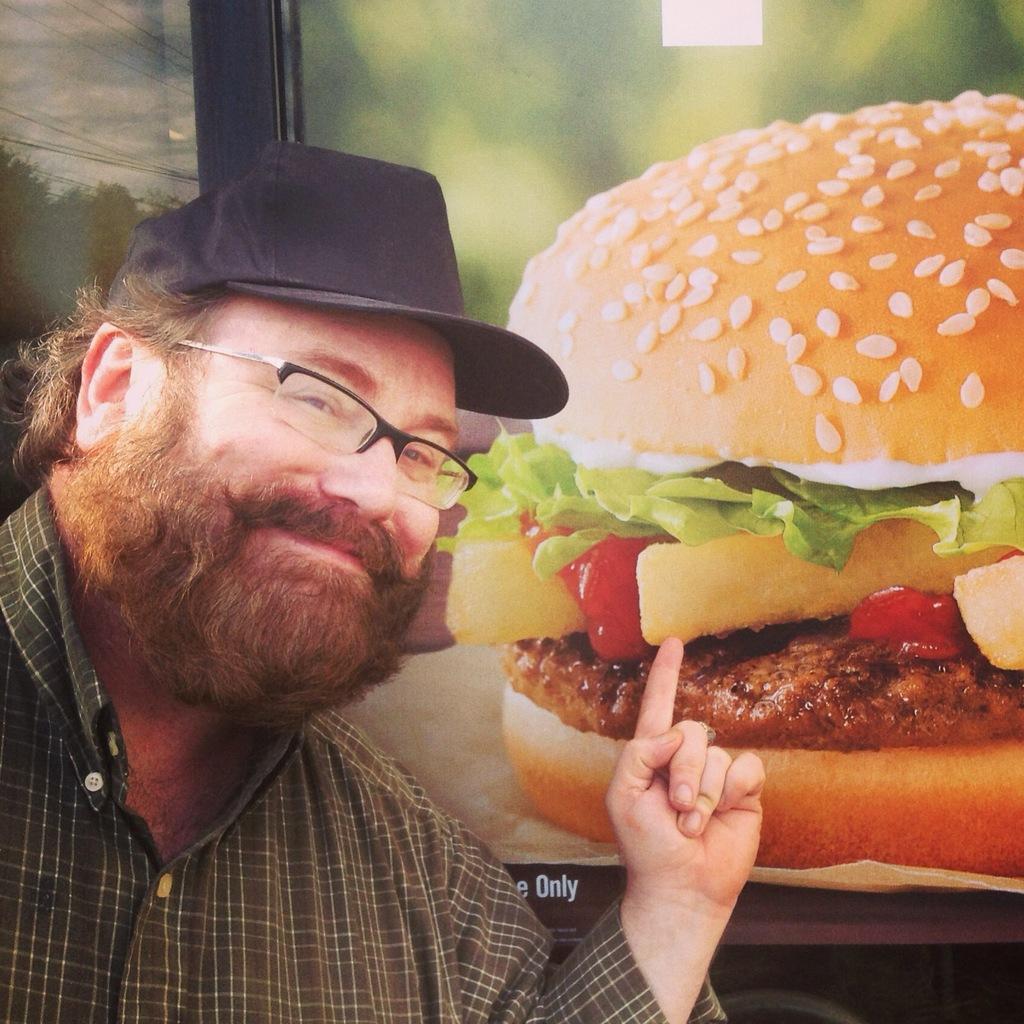Describe this image in one or two sentences. In the image I can see a man is pointing the finger in upward direction. The man is wearing a cap, spectacles and a shirt. In the background I can see photo of a burger. 